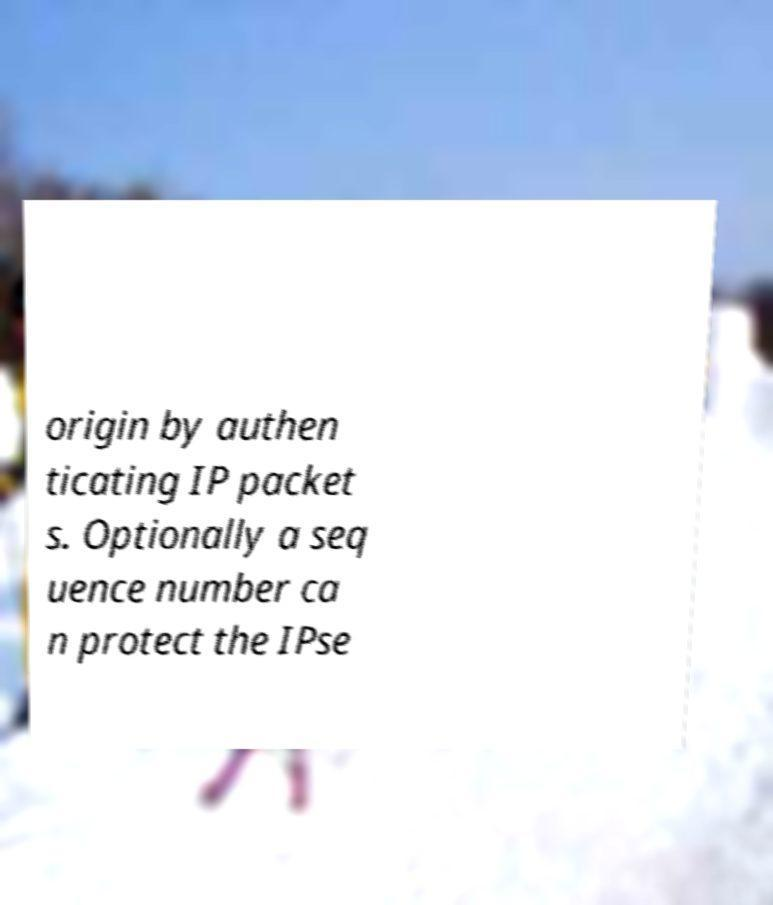Please identify and transcribe the text found in this image. origin by authen ticating IP packet s. Optionally a seq uence number ca n protect the IPse 